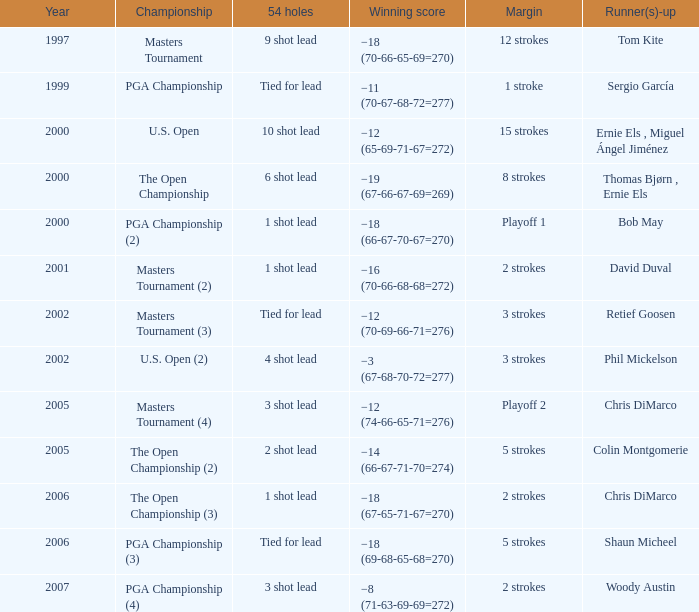In which margin does phil mickelson fall as a runner-up? 3 strokes. 